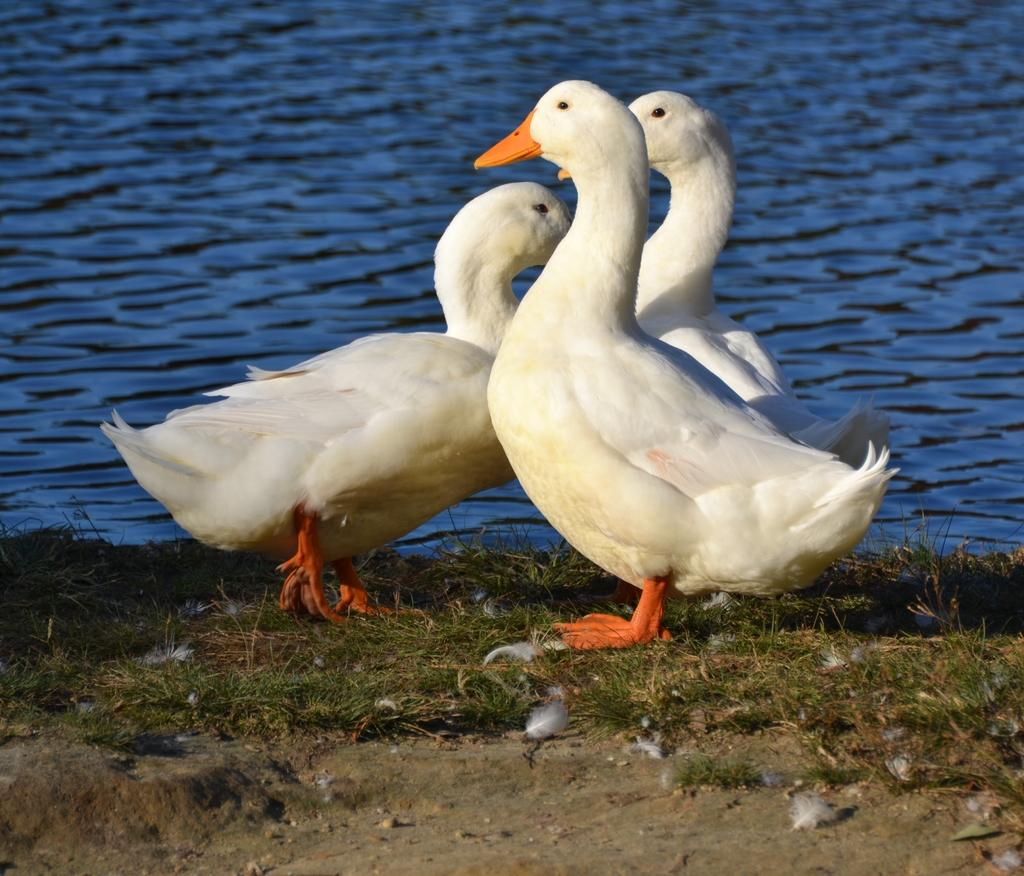How many ducks are in the image? There are three white ducks in the image. Where are the ducks located? The ducks are on the ground. What is visible behind the ducks? There is water visible behind the ducks. What type of vegetation is present on the ground? There is grass on the ground. What other type of ground surface can be seen? There is sand on the ground. What type of pest can be seen crawling on the chair in the image? There is no chair present in the image, and therefore no pest can be observed. 